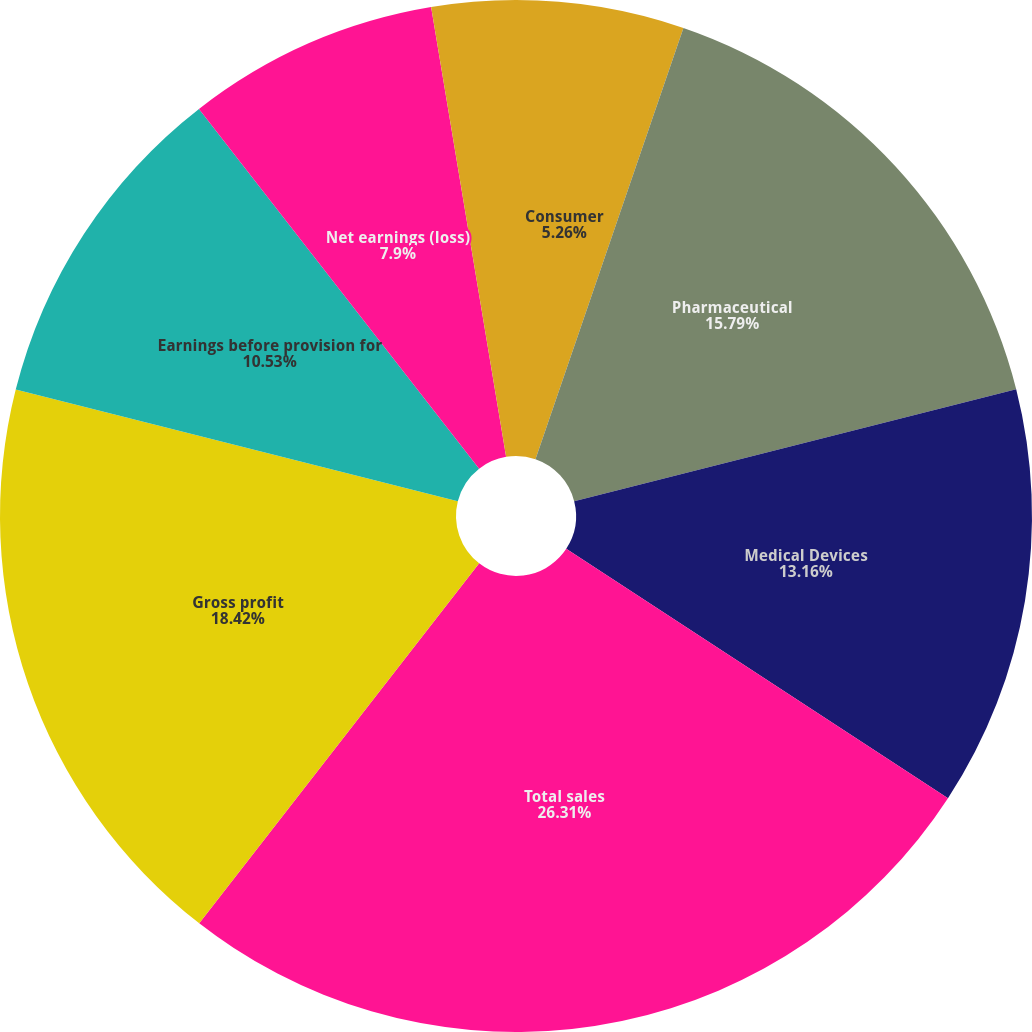Convert chart to OTSL. <chart><loc_0><loc_0><loc_500><loc_500><pie_chart><fcel>Consumer<fcel>Pharmaceutical<fcel>Medical Devices<fcel>Total sales<fcel>Gross profit<fcel>Earnings before provision for<fcel>Net earnings (loss)<fcel>Basic net earnings (loss) per<fcel>Diluted net earnings (loss)<nl><fcel>5.26%<fcel>15.79%<fcel>13.16%<fcel>26.31%<fcel>18.42%<fcel>10.53%<fcel>7.9%<fcel>2.63%<fcel>0.0%<nl></chart> 